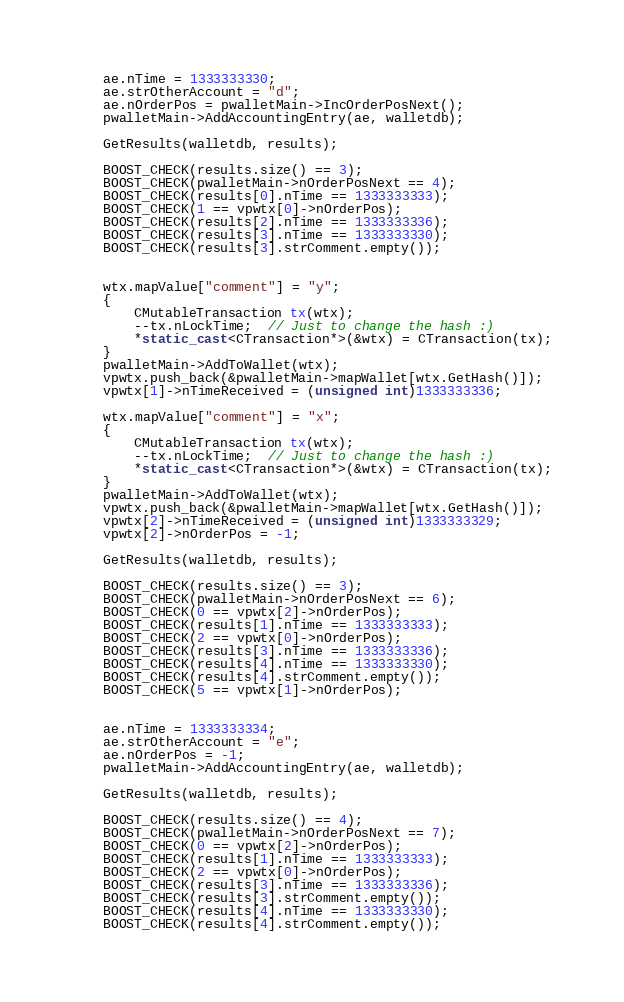<code> <loc_0><loc_0><loc_500><loc_500><_C++_>

    ae.nTime = 1333333330;
    ae.strOtherAccount = "d";
    ae.nOrderPos = pwalletMain->IncOrderPosNext();
    pwalletMain->AddAccountingEntry(ae, walletdb);

    GetResults(walletdb, results);

    BOOST_CHECK(results.size() == 3);
    BOOST_CHECK(pwalletMain->nOrderPosNext == 4);
    BOOST_CHECK(results[0].nTime == 1333333333);
    BOOST_CHECK(1 == vpwtx[0]->nOrderPos);
    BOOST_CHECK(results[2].nTime == 1333333336);
    BOOST_CHECK(results[3].nTime == 1333333330);
    BOOST_CHECK(results[3].strComment.empty());


    wtx.mapValue["comment"] = "y";
    {
        CMutableTransaction tx(wtx);
        --tx.nLockTime;  // Just to change the hash :)
        *static_cast<CTransaction*>(&wtx) = CTransaction(tx);
    }
    pwalletMain->AddToWallet(wtx);
    vpwtx.push_back(&pwalletMain->mapWallet[wtx.GetHash()]);
    vpwtx[1]->nTimeReceived = (unsigned int)1333333336;

    wtx.mapValue["comment"] = "x";
    {
        CMutableTransaction tx(wtx);
        --tx.nLockTime;  // Just to change the hash :)
        *static_cast<CTransaction*>(&wtx) = CTransaction(tx);
    }
    pwalletMain->AddToWallet(wtx);
    vpwtx.push_back(&pwalletMain->mapWallet[wtx.GetHash()]);
    vpwtx[2]->nTimeReceived = (unsigned int)1333333329;
    vpwtx[2]->nOrderPos = -1;

    GetResults(walletdb, results);

    BOOST_CHECK(results.size() == 3);
    BOOST_CHECK(pwalletMain->nOrderPosNext == 6);
    BOOST_CHECK(0 == vpwtx[2]->nOrderPos);
    BOOST_CHECK(results[1].nTime == 1333333333);
    BOOST_CHECK(2 == vpwtx[0]->nOrderPos);
    BOOST_CHECK(results[3].nTime == 1333333336);
    BOOST_CHECK(results[4].nTime == 1333333330);
    BOOST_CHECK(results[4].strComment.empty());
    BOOST_CHECK(5 == vpwtx[1]->nOrderPos);


    ae.nTime = 1333333334;
    ae.strOtherAccount = "e";
    ae.nOrderPos = -1;
    pwalletMain->AddAccountingEntry(ae, walletdb);

    GetResults(walletdb, results);

    BOOST_CHECK(results.size() == 4);
    BOOST_CHECK(pwalletMain->nOrderPosNext == 7);
    BOOST_CHECK(0 == vpwtx[2]->nOrderPos);
    BOOST_CHECK(results[1].nTime == 1333333333);
    BOOST_CHECK(2 == vpwtx[0]->nOrderPos);
    BOOST_CHECK(results[3].nTime == 1333333336);
    BOOST_CHECK(results[3].strComment.empty());
    BOOST_CHECK(results[4].nTime == 1333333330);
    BOOST_CHECK(results[4].strComment.empty());</code> 